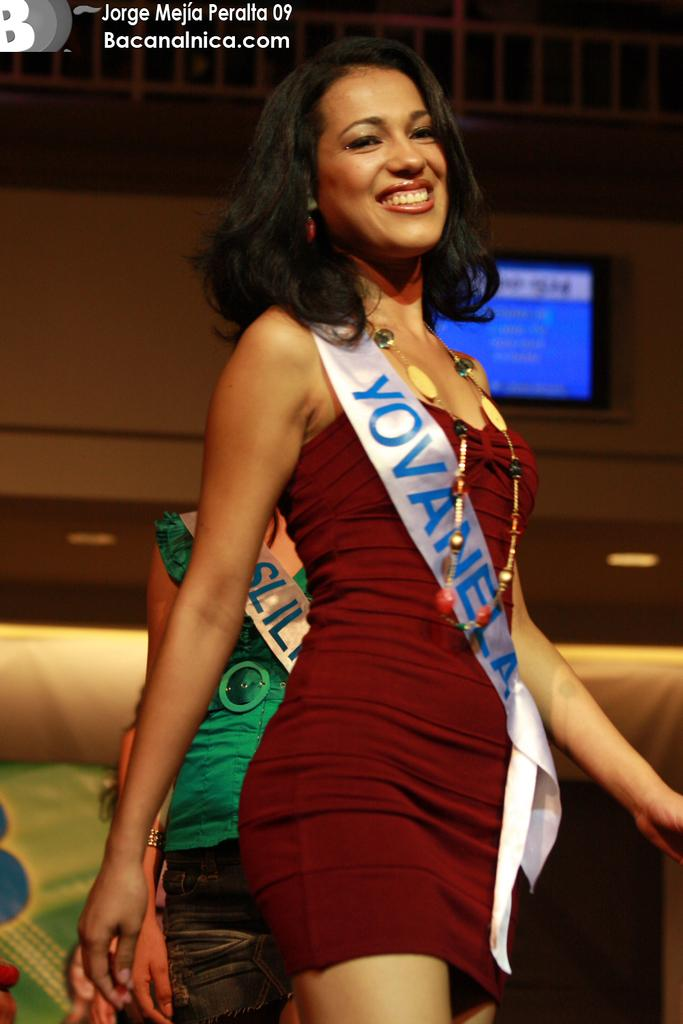<image>
Relay a brief, clear account of the picture shown. A woman in a red dress is wearing a sash that says Yovanela. 